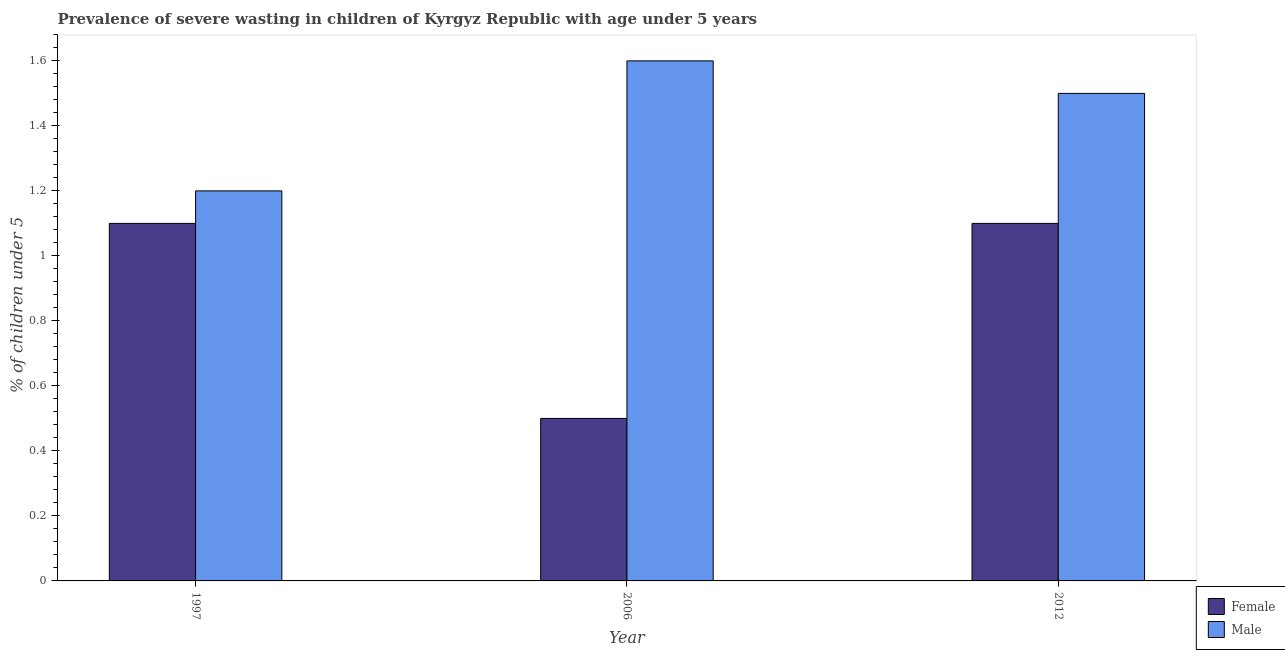How many groups of bars are there?
Your answer should be compact. 3. Are the number of bars per tick equal to the number of legend labels?
Ensure brevity in your answer.  Yes. Are the number of bars on each tick of the X-axis equal?
Keep it short and to the point. Yes. What is the percentage of undernourished male children in 2012?
Your answer should be compact. 1.5. Across all years, what is the maximum percentage of undernourished male children?
Give a very brief answer. 1.6. What is the total percentage of undernourished female children in the graph?
Keep it short and to the point. 2.7. What is the difference between the percentage of undernourished female children in 2006 and that in 2012?
Your response must be concise. -0.6. What is the difference between the percentage of undernourished female children in 1997 and the percentage of undernourished male children in 2006?
Keep it short and to the point. 0.6. What is the average percentage of undernourished female children per year?
Provide a succinct answer. 0.9. In how many years, is the percentage of undernourished female children greater than 1.6400000000000001 %?
Offer a very short reply. 0. What is the ratio of the percentage of undernourished female children in 2006 to that in 2012?
Give a very brief answer. 0.45. What is the difference between the highest and the second highest percentage of undernourished male children?
Give a very brief answer. 0.1. What is the difference between the highest and the lowest percentage of undernourished female children?
Provide a short and direct response. 0.6. In how many years, is the percentage of undernourished female children greater than the average percentage of undernourished female children taken over all years?
Your response must be concise. 2. Is the sum of the percentage of undernourished male children in 1997 and 2012 greater than the maximum percentage of undernourished female children across all years?
Provide a succinct answer. Yes. What does the 2nd bar from the right in 1997 represents?
Provide a short and direct response. Female. How many bars are there?
Provide a short and direct response. 6. Are all the bars in the graph horizontal?
Your response must be concise. No. How many years are there in the graph?
Make the answer very short. 3. What is the difference between two consecutive major ticks on the Y-axis?
Ensure brevity in your answer.  0.2. Does the graph contain any zero values?
Offer a very short reply. No. Does the graph contain grids?
Your answer should be compact. No. Where does the legend appear in the graph?
Provide a succinct answer. Bottom right. How many legend labels are there?
Offer a very short reply. 2. How are the legend labels stacked?
Your response must be concise. Vertical. What is the title of the graph?
Keep it short and to the point. Prevalence of severe wasting in children of Kyrgyz Republic with age under 5 years. Does "Register a property" appear as one of the legend labels in the graph?
Keep it short and to the point. No. What is the label or title of the Y-axis?
Keep it short and to the point.  % of children under 5. What is the  % of children under 5 of Female in 1997?
Your answer should be very brief. 1.1. What is the  % of children under 5 in Male in 1997?
Your answer should be compact. 1.2. What is the  % of children under 5 in Female in 2006?
Your response must be concise. 0.5. What is the  % of children under 5 in Male in 2006?
Provide a short and direct response. 1.6. What is the  % of children under 5 in Female in 2012?
Your answer should be very brief. 1.1. Across all years, what is the maximum  % of children under 5 in Female?
Provide a short and direct response. 1.1. Across all years, what is the maximum  % of children under 5 of Male?
Your response must be concise. 1.6. Across all years, what is the minimum  % of children under 5 in Female?
Your answer should be compact. 0.5. Across all years, what is the minimum  % of children under 5 in Male?
Keep it short and to the point. 1.2. What is the total  % of children under 5 of Male in the graph?
Ensure brevity in your answer.  4.3. What is the difference between the  % of children under 5 of Male in 1997 and that in 2006?
Offer a terse response. -0.4. What is the difference between the  % of children under 5 in Female in 2006 and that in 2012?
Provide a short and direct response. -0.6. What is the average  % of children under 5 in Male per year?
Make the answer very short. 1.43. In the year 2012, what is the difference between the  % of children under 5 of Female and  % of children under 5 of Male?
Your response must be concise. -0.4. What is the ratio of the  % of children under 5 of Male in 1997 to that in 2006?
Provide a short and direct response. 0.75. What is the ratio of the  % of children under 5 in Female in 2006 to that in 2012?
Ensure brevity in your answer.  0.45. What is the ratio of the  % of children under 5 of Male in 2006 to that in 2012?
Give a very brief answer. 1.07. What is the difference between the highest and the second highest  % of children under 5 of Female?
Keep it short and to the point. 0. 